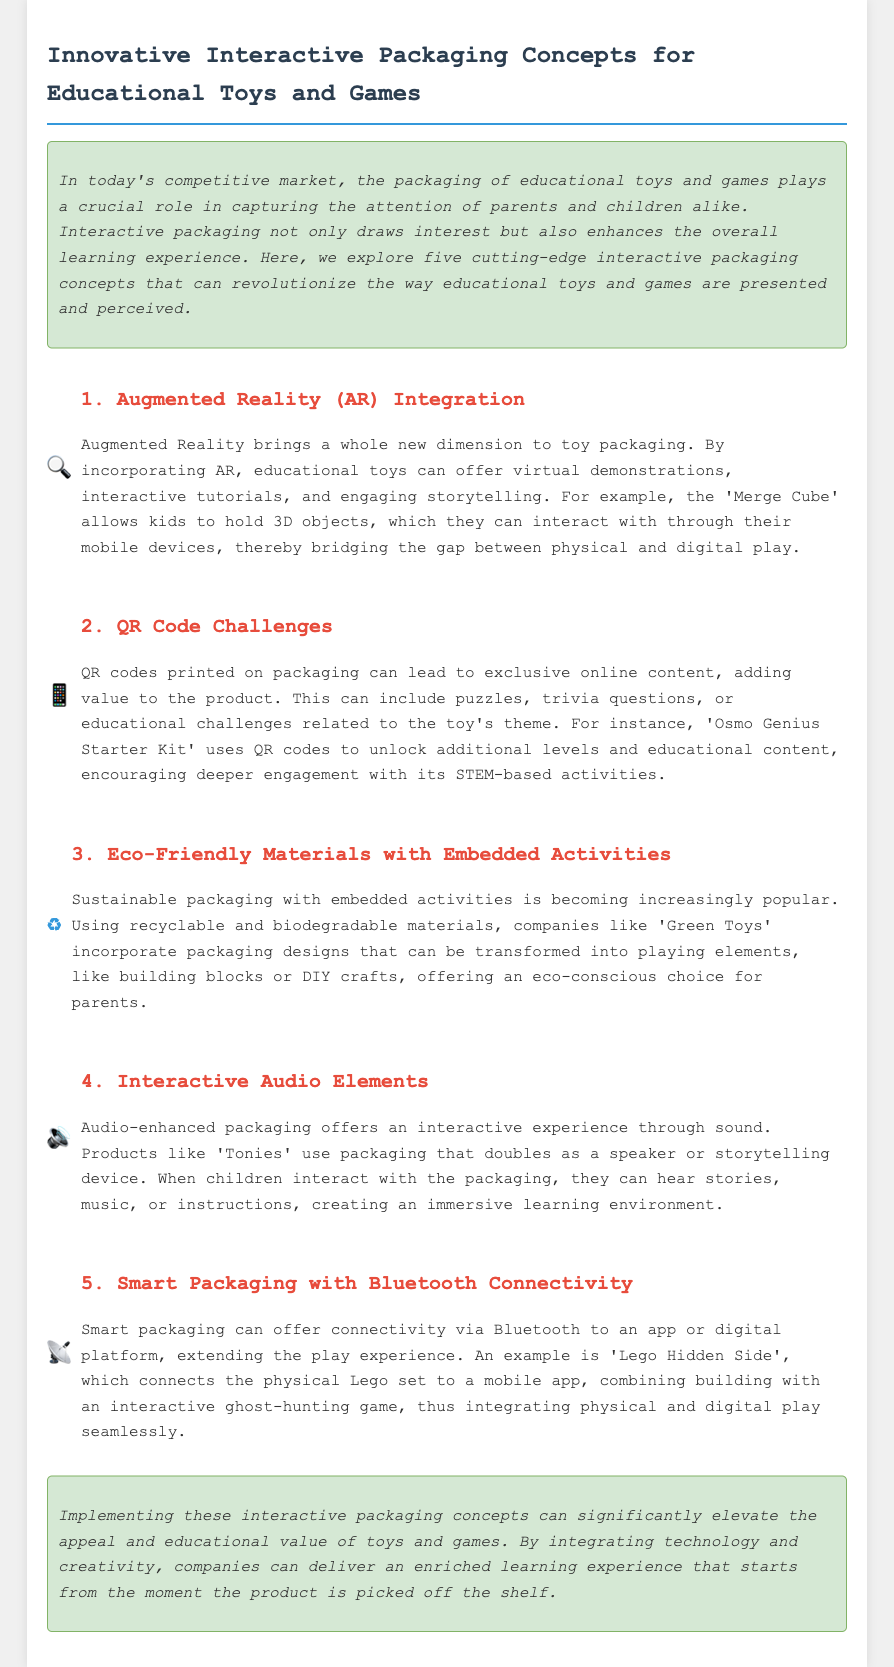what is the first interactive packaging concept mentioned? The first interactive packaging concept discussed in the document is "Augmented Reality (AR) Integration".
Answer: Augmented Reality (AR) Integration how many interactive packaging concepts are presented? The document outlines a total of five interactive packaging concepts.
Answer: five what is a feature of the 'Osmo Genius Starter Kit'? The 'Osmo Genius Starter Kit' uses QR codes to unlock additional levels and educational content.
Answer: QR codes to unlock additional levels which company uses sustainable packaging designs? The company 'Green Toys' is mentioned for incorporating sustainable packaging designs that can be transformed into playing elements.
Answer: Green Toys what interactive element does 'Tonies' packaging provide? 'Tonies' packaging provides an interactive audio experience through sound.
Answer: interactive audio experience which technology is used in 'Lego Hidden Side'? 'Lego Hidden Side' uses Bluetooth connectivity to connect the physical Lego set to a mobile app.
Answer: Bluetooth connectivity what is a benefit of eco-friendly materials in packaging? Eco-friendly materials with embedded activities offer an eco-conscious choice for parents while also incorporating playful elements.
Answer: eco-conscious choice for parents how does augmented reality enhance educational toys? Augmented Reality allows educational toys to offer virtual demonstrations, interactive tutorials, and storytelling.
Answer: virtual demonstrations, interactive tutorials, and storytelling 